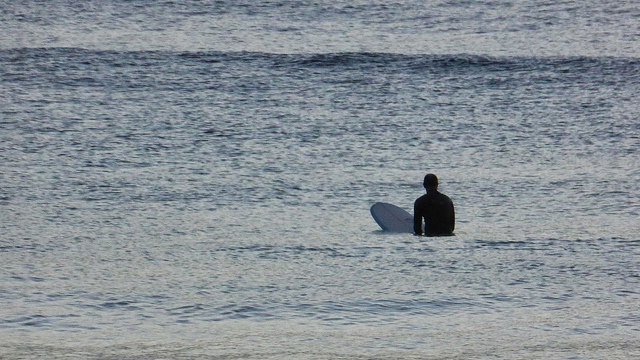Describe the objects in this image and their specific colors. I can see people in gray, black, navy, and darkgray tones and surfboard in gray, darkblue, navy, and darkgray tones in this image. 